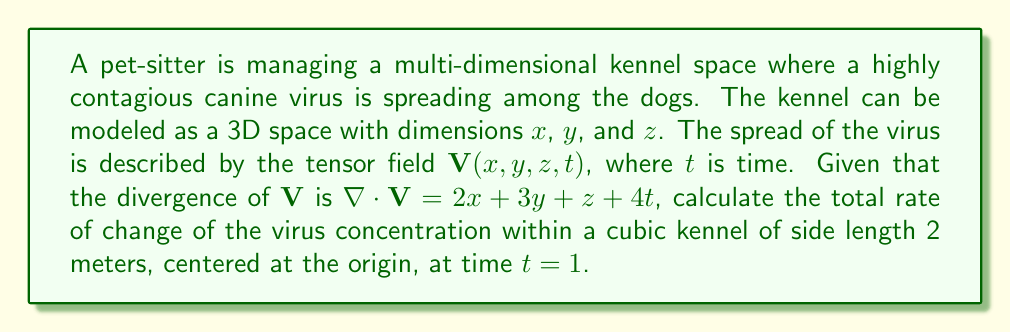Can you answer this question? To solve this problem, we'll follow these steps:

1) The divergence theorem states that the volume integral of the divergence of a vector field over a volume is equal to the surface integral of the vector field over the surface that bounds the volume. In tensor notation:

   $$\int_V \nabla \cdot \mathbf{V} \, dV = \oint_S \mathbf{V} \cdot d\mathbf{S}$$

2) The left side of this equation represents the total rate of change of the virus concentration within the volume.

3) We're given that $\nabla \cdot \mathbf{V} = 2x + 3y + z + 4t$. At $t=1$, this becomes:
   
   $$\nabla \cdot \mathbf{V} = 2x + 3y + z + 4$$

4) The kennel is a cube centered at the origin with side length 2. Its bounds are:
   $-1 \leq x \leq 1$, $-1 \leq y \leq 1$, $-1 \leq z \leq 1$

5) We need to integrate this over the volume of the cube:

   $$\int_{-1}^1 \int_{-1}^1 \int_{-1}^1 (2x + 3y + z + 4) \, dx \, dy \, dz$$

6) Let's integrate with respect to x first:

   $$\int_{-1}^1 \int_{-1}^1 [(x^2 + 3xy + xz + 4x)]_{-1}^1 \, dy \, dz$$
   $$= \int_{-1}^1 \int_{-1}^1 (2 + 3y + z + 4) \, dy \, dz$$

7) Now integrate with respect to y:

   $$\int_{-1}^1 [(2y + \frac{3}{2}y^2 + yz + 4y)]_{-1}^1 \, dz$$
   $$= \int_{-1}^1 (4 + 3 + 2z + 8) \, dz$$
   $$= \int_{-1}^1 (15 + 2z) \, dz$$

8) Finally, integrate with respect to z:

   $$[(15z + z^2)]_{-1}^1$$
   $$= (15 + 1) - (-15 + 1) = 30$$

Therefore, the total rate of change of the virus concentration within the cubic kennel at time $t=1$ is 30 units per unit time.
Answer: 30 units/time 